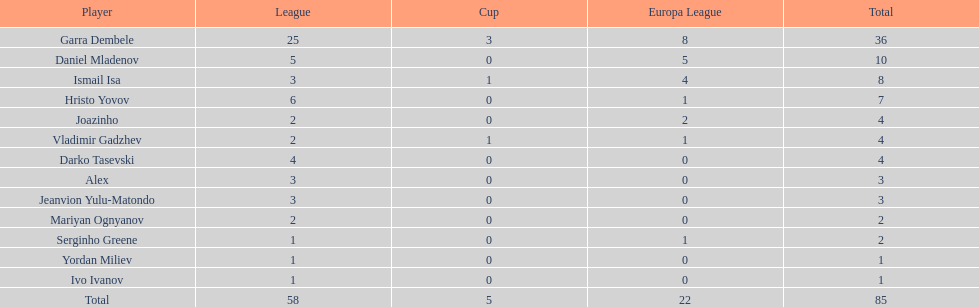What is the sum of the cup total and the europa league total? 27. 